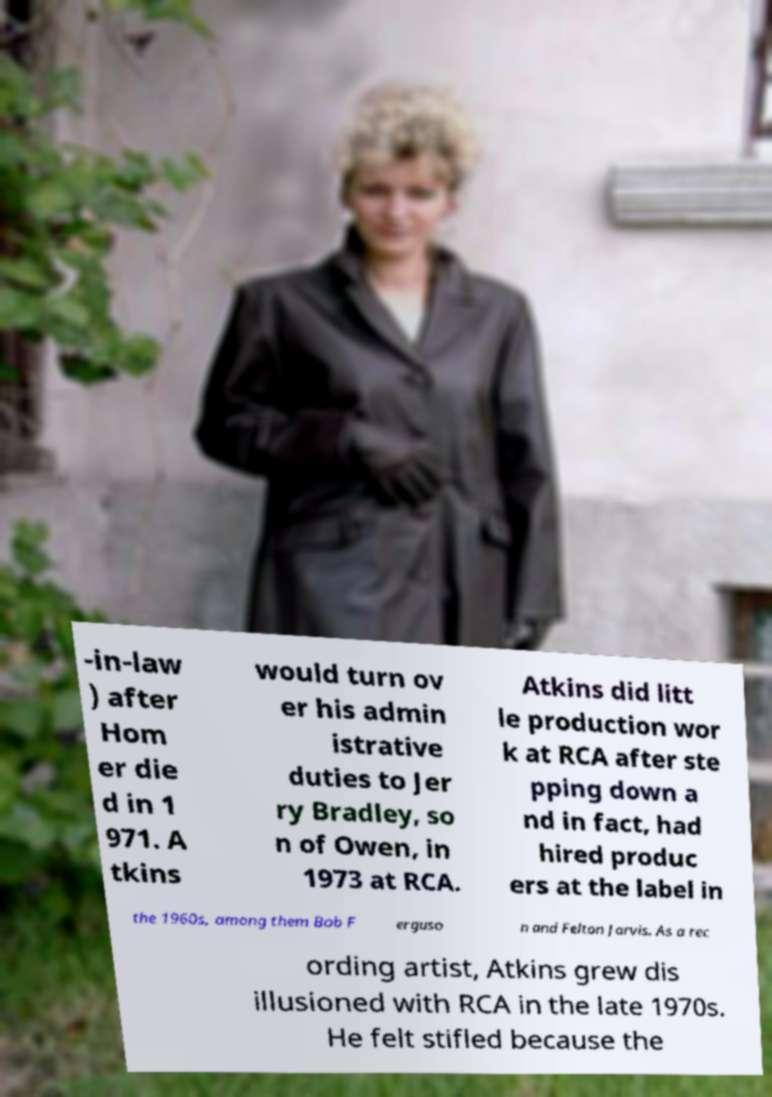What messages or text are displayed in this image? I need them in a readable, typed format. -in-law ) after Hom er die d in 1 971. A tkins would turn ov er his admin istrative duties to Jer ry Bradley, so n of Owen, in 1973 at RCA. Atkins did litt le production wor k at RCA after ste pping down a nd in fact, had hired produc ers at the label in the 1960s, among them Bob F erguso n and Felton Jarvis. As a rec ording artist, Atkins grew dis illusioned with RCA in the late 1970s. He felt stifled because the 